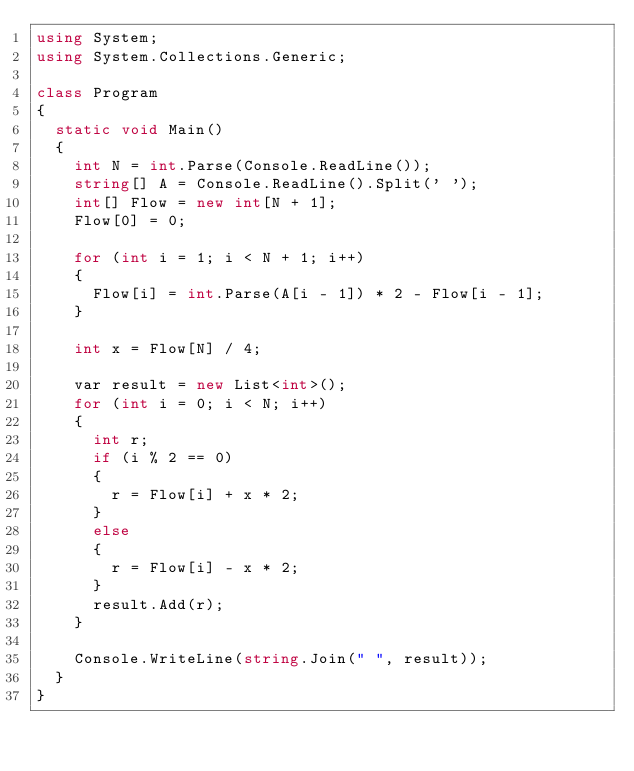<code> <loc_0><loc_0><loc_500><loc_500><_C#_>using System;
using System.Collections.Generic;

class Program
{
  static void Main()
  {
    int N = int.Parse(Console.ReadLine());
    string[] A = Console.ReadLine().Split(' ');
    int[] Flow = new int[N + 1];
    Flow[0] = 0;
    
    for (int i = 1; i < N + 1; i++)
    {
      Flow[i] = int.Parse(A[i - 1]) * 2 - Flow[i - 1];
    }
    
    int x = Flow[N] / 4;
    
    var result = new List<int>();
    for (int i = 0; i < N; i++)
    {
      int r;
      if (i % 2 == 0)
      {
        r = Flow[i] + x * 2;
      }
      else
      {
        r = Flow[i] - x * 2;
      }
      result.Add(r);
    }
    
    Console.WriteLine(string.Join(" ", result));
  }
}</code> 